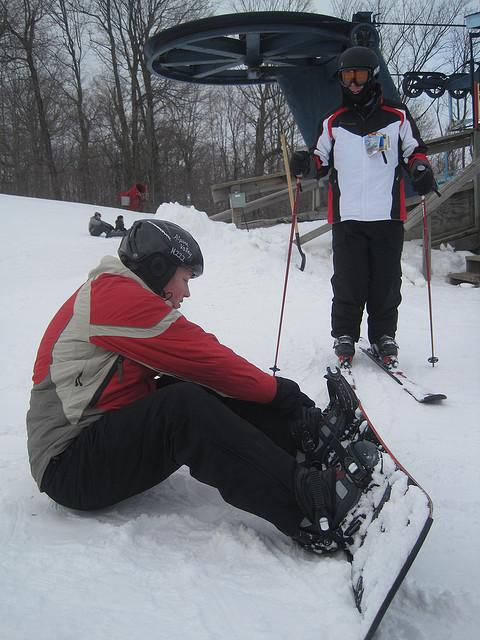What is on the ground?
Answer briefly. Snow. What is the season?
Quick response, please. Winter. Why is this person sitting down?
Be succinct. Yes. 